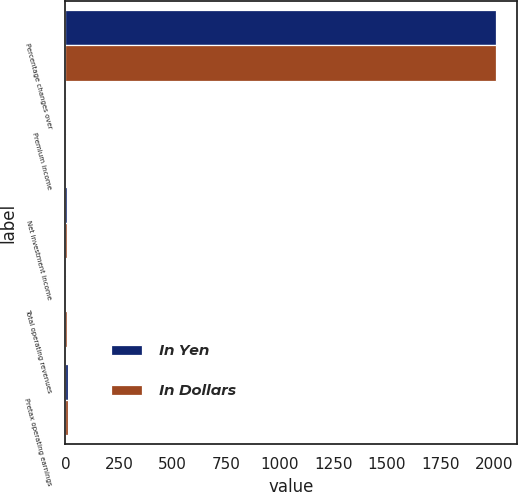Convert chart to OTSL. <chart><loc_0><loc_0><loc_500><loc_500><stacked_bar_chart><ecel><fcel>Percentage changes over<fcel>Premium income<fcel>Net investment income<fcel>Total operating revenues<fcel>Pretax operating earnings<nl><fcel>In Yen<fcel>2007<fcel>3.1<fcel>6.7<fcel>3.7<fcel>10.2<nl><fcel>In Dollars<fcel>2007<fcel>4.3<fcel>8<fcel>4.9<fcel>11.8<nl></chart> 